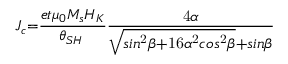Convert formula to latex. <formula><loc_0><loc_0><loc_500><loc_500>J _ { c } = \frac { e t { \mu } _ { 0 } M _ { s } H _ { K } } { { \theta } _ { S H } \hslash } \frac { 4 \alpha } { \sqrt { \sin ^ { 2 } \beta + 1 6 { \alpha } ^ { 2 } \cos ^ { 2 } \beta } + \sin \beta }</formula> 